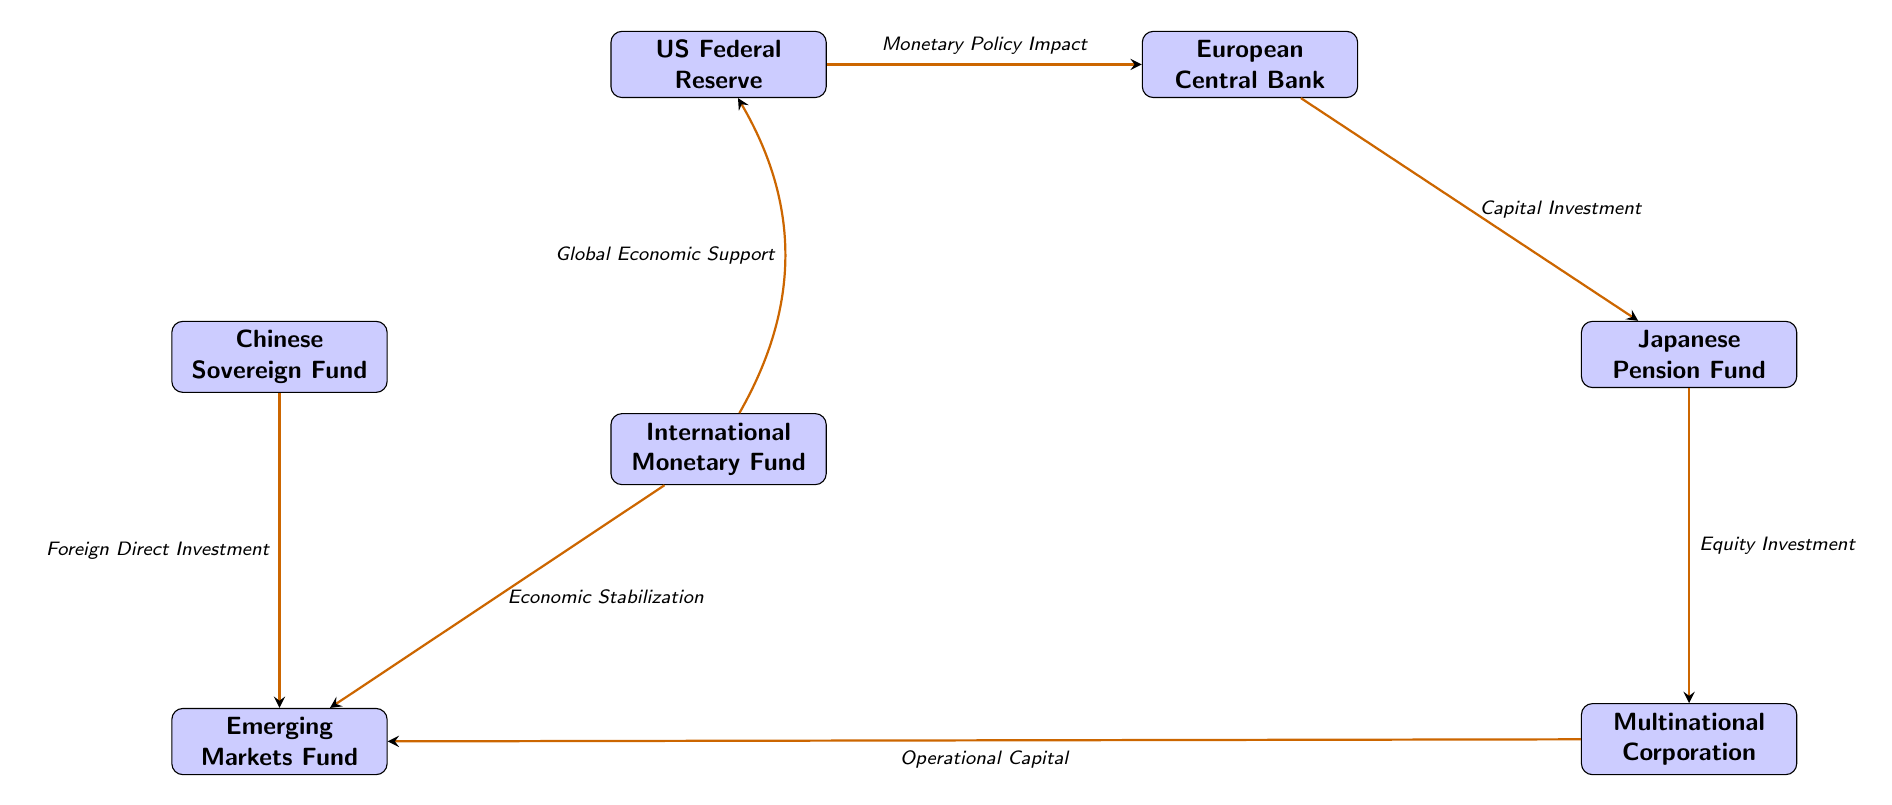What is the total number of nodes in the diagram? The diagram contains a total of 6 entities represented as rectangles: US Federal Reserve, European Central Bank, Japanese Pension Fund, Chinese Sovereign Fund, Emerging Markets Fund, and Multinational Corporation. Therefore, the total is 6 nodes.
Answer: 6 Which node is connected to both the US Federal Reserve and the Emerging Markets Fund? The International Monetary Fund (IMF) is the only node that has edges leading to both the US Federal Reserve and the Emerging Markets Fund, demonstrating its role in relaying global economic support and economic stabilization.
Answer: International Monetary Fund What type of investment connects the European Central Bank and the Japanese Pension Fund? The connection that goes from the European Central Bank to the Japanese Pension Fund indicates "Capital Investment". This shows the direction and type of flow between these two entities.
Answer: Capital Investment What effect does the Chinese Sovereign Fund have on the Emerging Markets Fund? The diagram specifies that the Chinese Sovereign Fund flows into the Emerging Markets Fund labeled as "Foreign Direct Investment". This indicates a direct financial influence the Chinese Sovereign Fund has over that fund.
Answer: Foreign Direct Investment Which two entities are directly connected through the equity investment flow? The flow labeled "Equity Investment" connects the Japanese Pension Fund (JPF) and the Multinational Corporation (MC). This represents the relationship where JPF invests in MC.
Answer: Japanese Pension Fund and Multinational Corporation What is the nature of the flow from the International Monetary Fund to the US Federal Reserve? The diagram indicates a flow labeled "Global Economic Support" going from the International Monetary Fund to the US Federal Reserve, indicating that the IMF provides support to the Fed in the global economic context.
Answer: Global Economic Support Which entity does the Multinational Corporation provide operational capital to? Based on the flow depicted in the diagram, the Multinational Corporation directs its operational capital towards the Emerging Markets Fund, highlighting its role in financing or supporting the operations within that fund.
Answer: Emerging Markets Fund What two flows are associated with the Emerging Markets Fund? The Emerging Markets Fund is connected by two flows: one labeled "Foreign Direct Investment" coming from the Chinese Sovereign Fund, and another labeled "Economic Stabilization" coming from the International Monetary Fund. This dual connection emphasizes the funding and stabilization role of the Fund in global finance.
Answer: Foreign Direct Investment, Economic Stabilization 